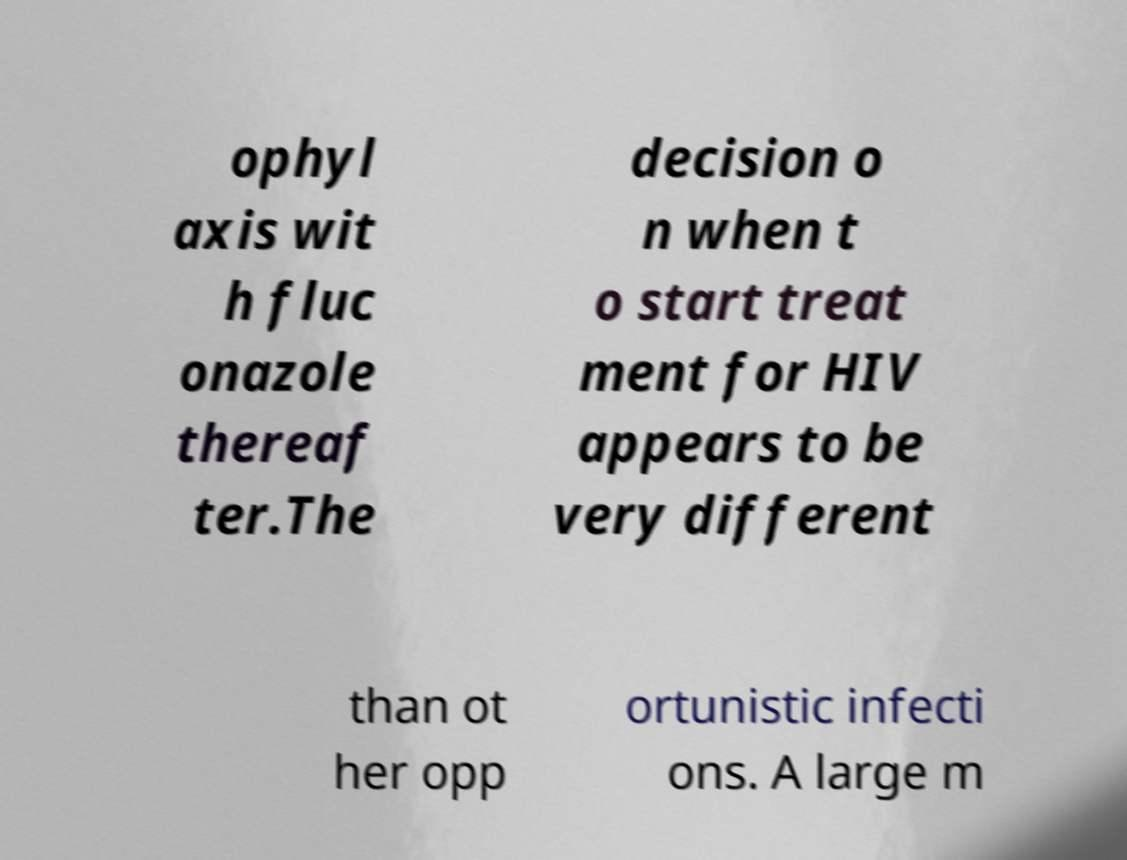Could you extract and type out the text from this image? ophyl axis wit h fluc onazole thereaf ter.The decision o n when t o start treat ment for HIV appears to be very different than ot her opp ortunistic infecti ons. A large m 